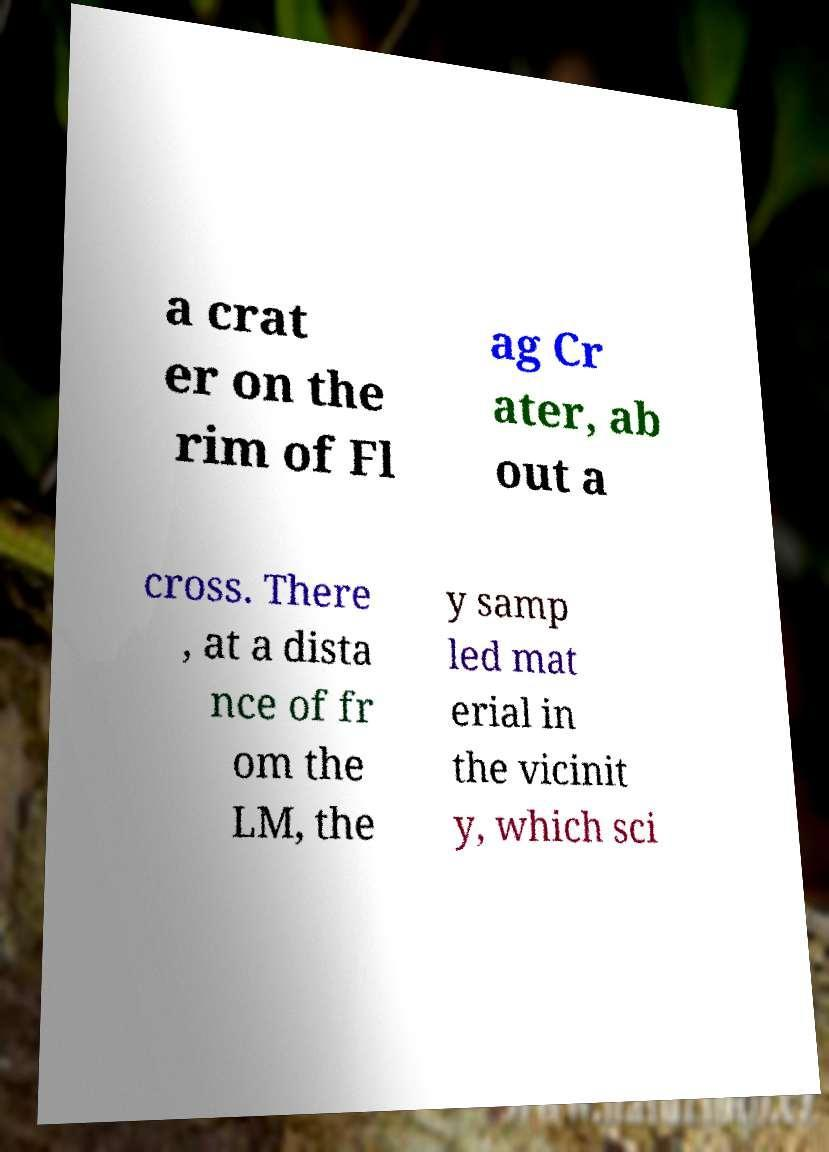There's text embedded in this image that I need extracted. Can you transcribe it verbatim? a crat er on the rim of Fl ag Cr ater, ab out a cross. There , at a dista nce of fr om the LM, the y samp led mat erial in the vicinit y, which sci 